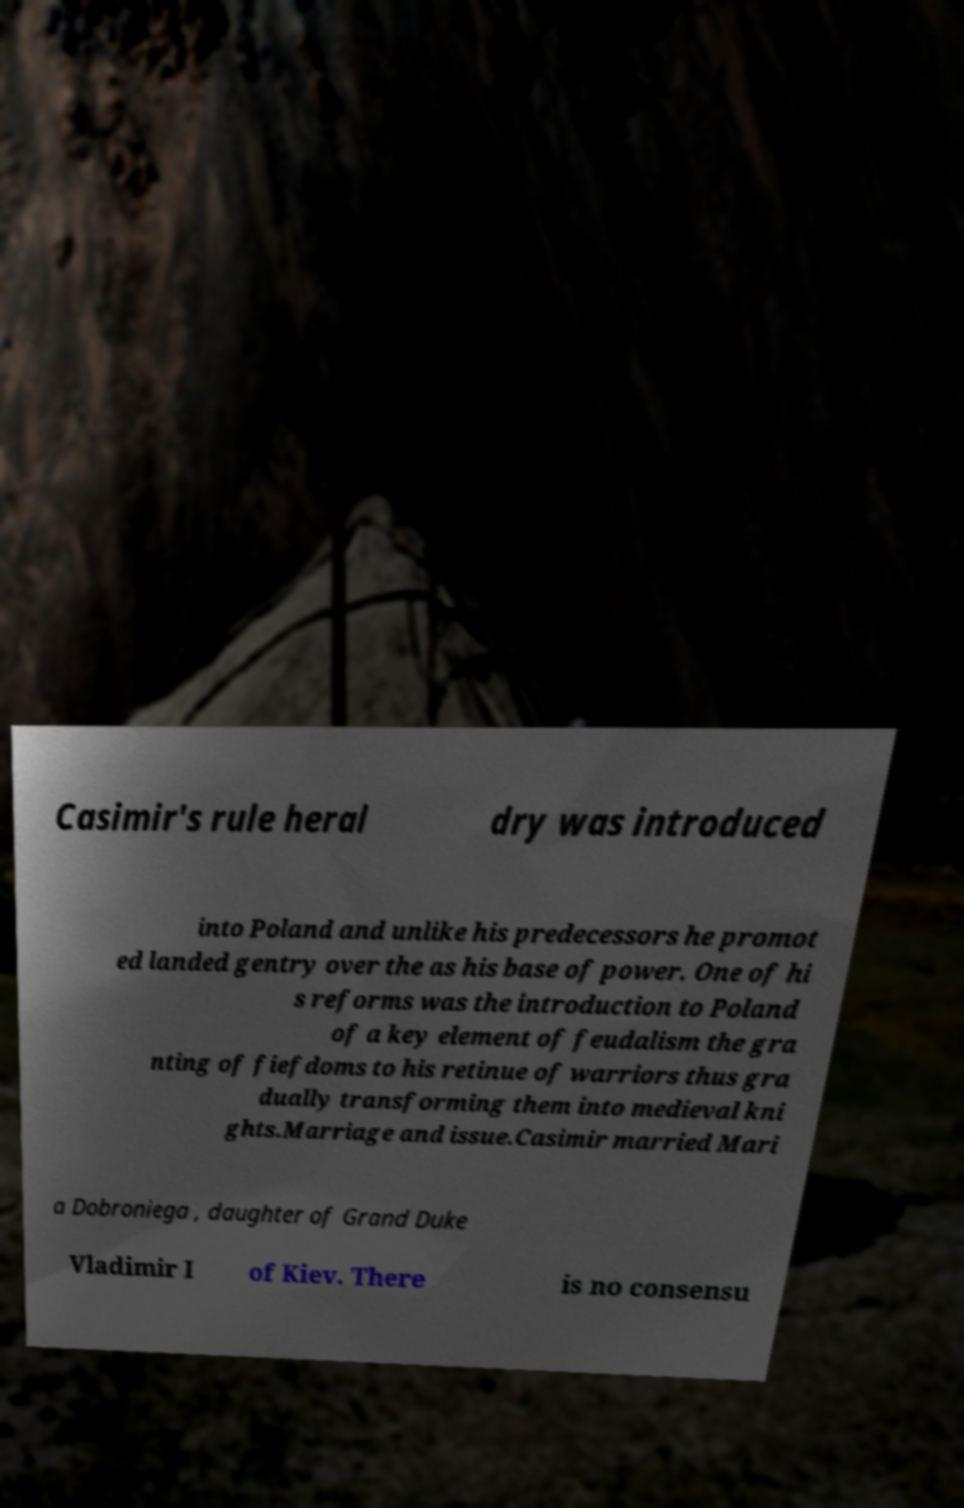Please read and relay the text visible in this image. What does it say? Casimir's rule heral dry was introduced into Poland and unlike his predecessors he promot ed landed gentry over the as his base of power. One of hi s reforms was the introduction to Poland of a key element of feudalism the gra nting of fiefdoms to his retinue of warriors thus gra dually transforming them into medieval kni ghts.Marriage and issue.Casimir married Mari a Dobroniega , daughter of Grand Duke Vladimir I of Kiev. There is no consensu 